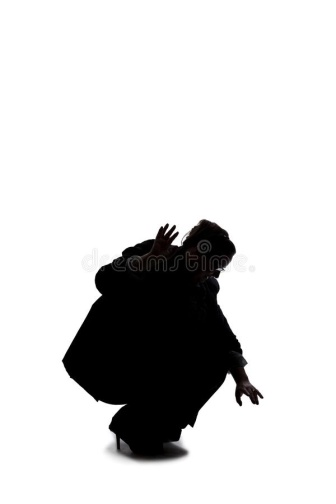Describe the following image. The image features a dramatic black and white scene. Dominating the composition is a silhouette of an individual crouching low to the ground. Their form is dynamic, with arms outstretched and hands shaped in claw-like positions, as if preparing to leap or seize something. The figure is oriented towards the right side of the frame, which imparts a sense of motion or anticipation to the image. The background is an unblemished white, enhancing the contrast and highlighting the solitary figure. The simplicity and starkness of the imagery draw all attention to the person's intense and dramatic posture. There is no text or additional objects present, focusing the narrative solely on the individual's striking form and movement. The absence of color and extraneous elements underscores the emotional weight and drama of the scene. 